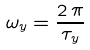<formula> <loc_0><loc_0><loc_500><loc_500>\omega _ { y } = \frac { 2 \, \pi } { \tau _ { y } }</formula> 